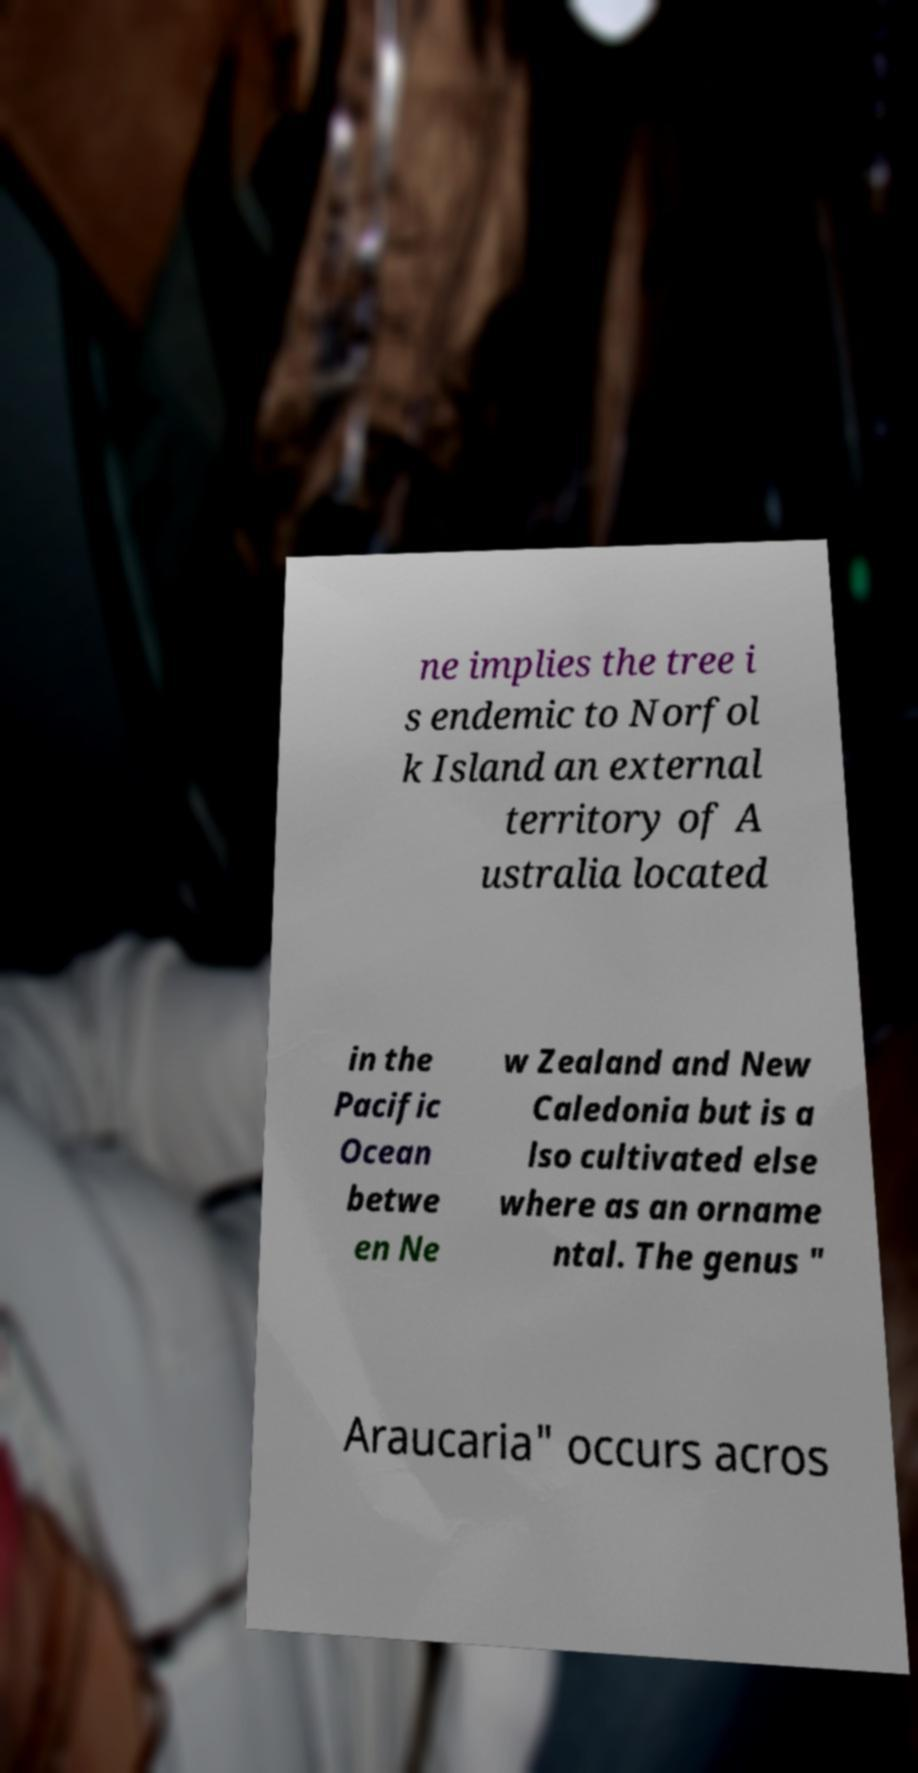There's text embedded in this image that I need extracted. Can you transcribe it verbatim? ne implies the tree i s endemic to Norfol k Island an external territory of A ustralia located in the Pacific Ocean betwe en Ne w Zealand and New Caledonia but is a lso cultivated else where as an orname ntal. The genus " Araucaria" occurs acros 